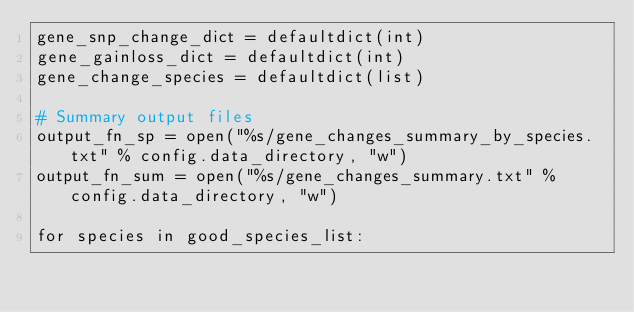Convert code to text. <code><loc_0><loc_0><loc_500><loc_500><_Python_>gene_snp_change_dict = defaultdict(int)
gene_gainloss_dict = defaultdict(int)
gene_change_species = defaultdict(list)

# Summary output files
output_fn_sp = open("%s/gene_changes_summary_by_species.txt" % config.data_directory, "w")
output_fn_sum = open("%s/gene_changes_summary.txt" % config.data_directory, "w")

for species in good_species_list:</code> 